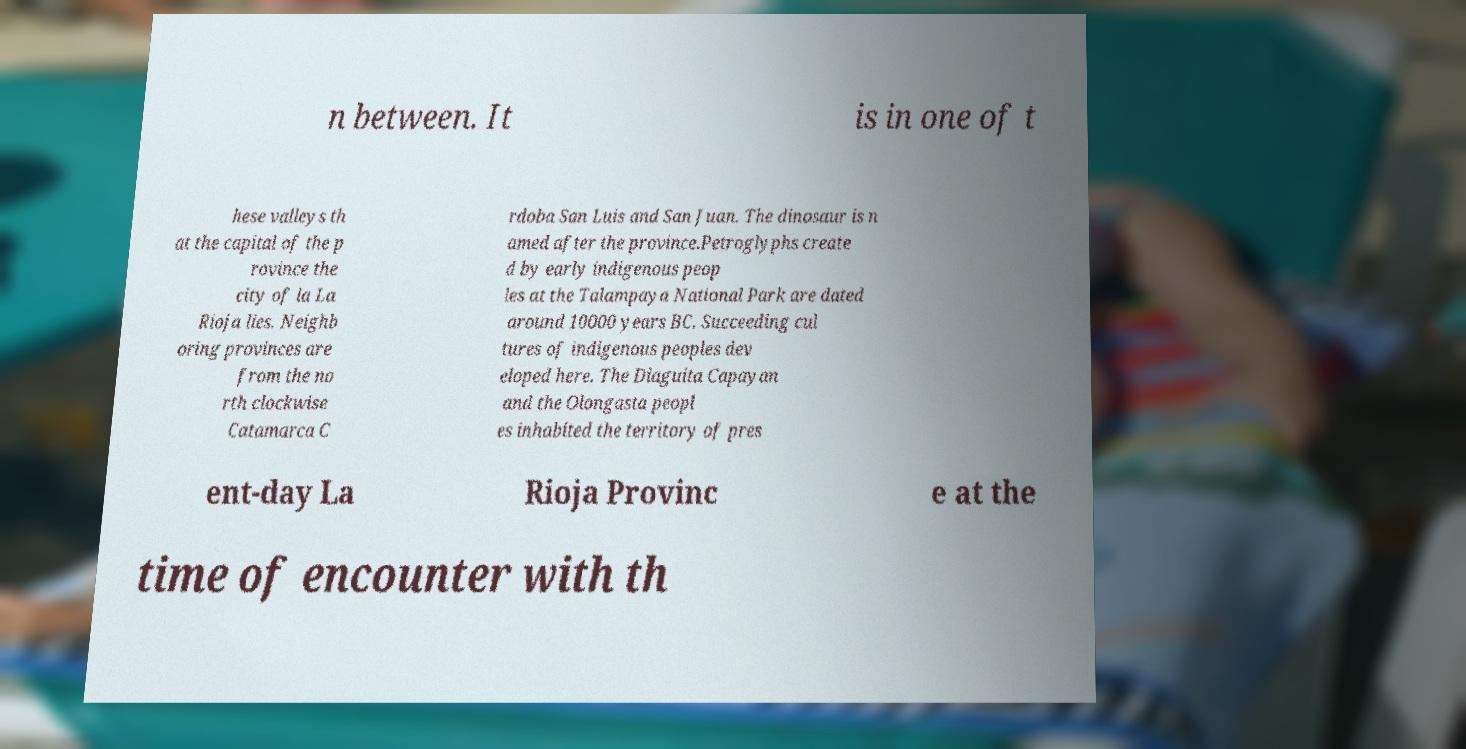There's text embedded in this image that I need extracted. Can you transcribe it verbatim? n between. It is in one of t hese valleys th at the capital of the p rovince the city of la La Rioja lies. Neighb oring provinces are from the no rth clockwise Catamarca C rdoba San Luis and San Juan. The dinosaur is n amed after the province.Petroglyphs create d by early indigenous peop les at the Talampaya National Park are dated around 10000 years BC. Succeeding cul tures of indigenous peoples dev eloped here. The Diaguita Capayan and the Olongasta peopl es inhabited the territory of pres ent-day La Rioja Provinc e at the time of encounter with th 